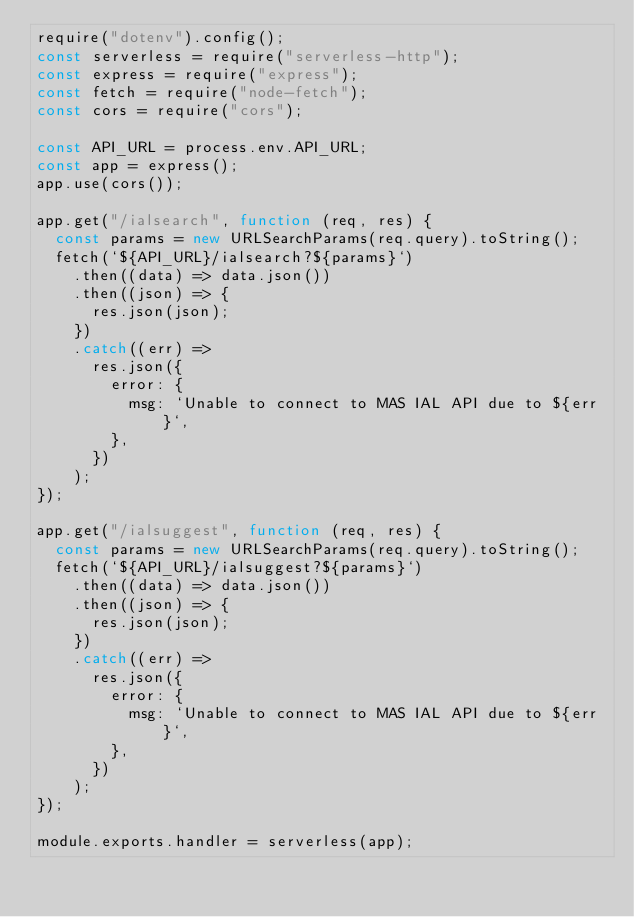<code> <loc_0><loc_0><loc_500><loc_500><_JavaScript_>require("dotenv").config();
const serverless = require("serverless-http");
const express = require("express");
const fetch = require("node-fetch");
const cors = require("cors");

const API_URL = process.env.API_URL;
const app = express();
app.use(cors());

app.get("/ialsearch", function (req, res) {
  const params = new URLSearchParams(req.query).toString();
  fetch(`${API_URL}/ialsearch?${params}`)
    .then((data) => data.json())
    .then((json) => {
      res.json(json);
    })
    .catch((err) =>
      res.json({
        error: {
          msg: `Unable to connect to MAS IAL API due to ${err}`,
        },
      })
    );
});

app.get("/ialsuggest", function (req, res) {
  const params = new URLSearchParams(req.query).toString();
  fetch(`${API_URL}/ialsuggest?${params}`)
    .then((data) => data.json())
    .then((json) => {
      res.json(json);
    })
    .catch((err) =>
      res.json({
        error: {
          msg: `Unable to connect to MAS IAL API due to ${err}`,
        },
      })
    );
});

module.exports.handler = serverless(app);
</code> 